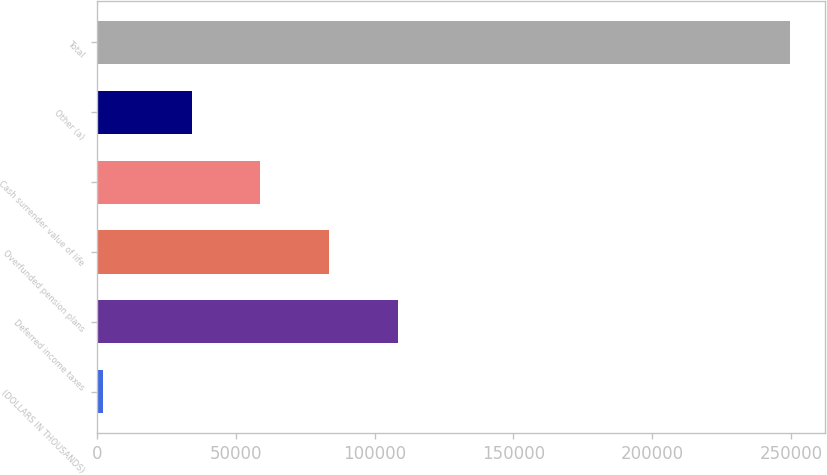Convert chart. <chart><loc_0><loc_0><loc_500><loc_500><bar_chart><fcel>(DOLLARS IN THOUSANDS)<fcel>Deferred income taxes<fcel>Overfunded pension plans<fcel>Cash surrender value of life<fcel>Other (a)<fcel>Total<nl><fcel>2017<fcel>108255<fcel>83484<fcel>58713<fcel>33942<fcel>249727<nl></chart> 